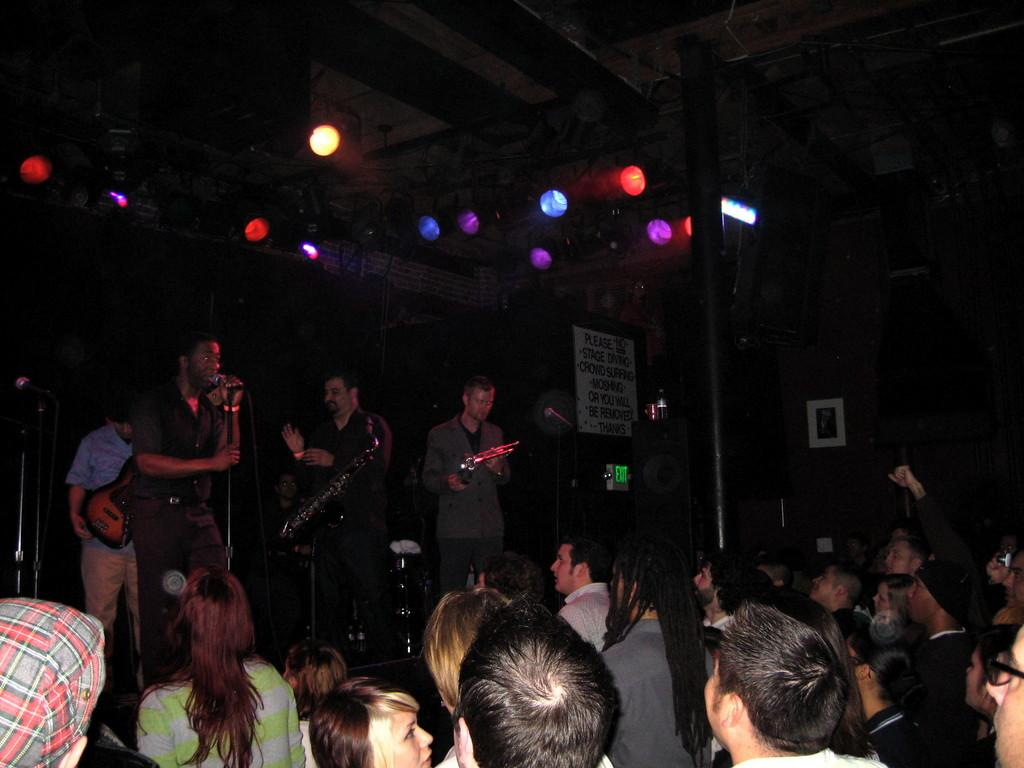What are the people in the image doing? There is a group of people playing music in the image. Who is present in the image besides the musicians? There is an audience in front of the musicians. What type of wave can be seen crashing on the shore in the image? There is no wave or shore present in the image; it features a group of people playing music and an audience. 